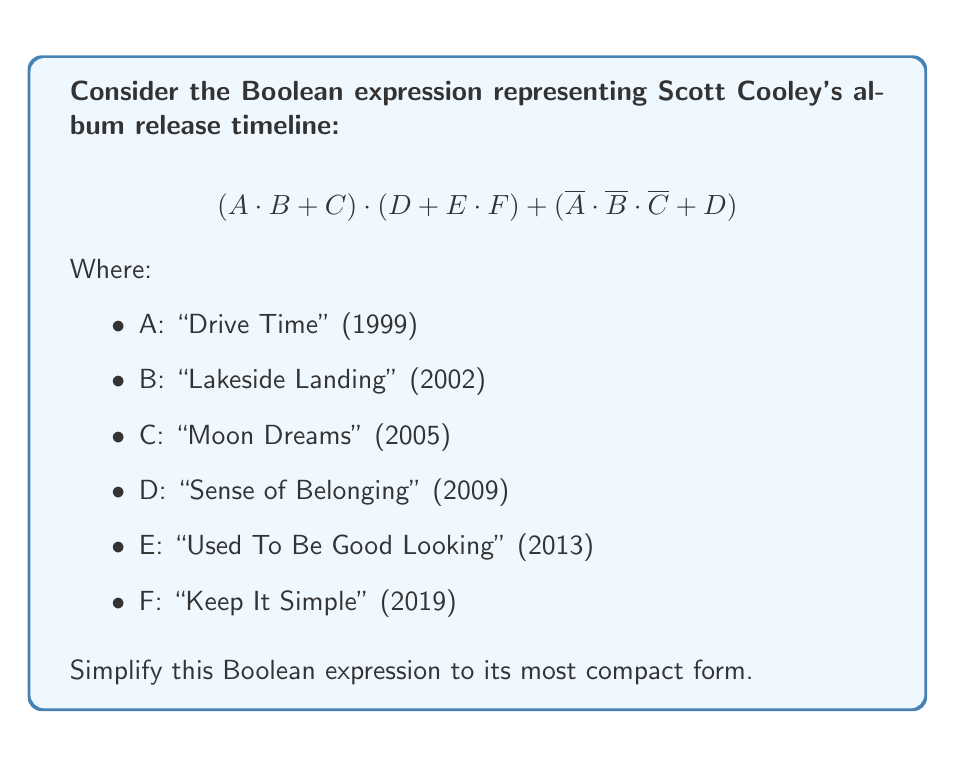Give your solution to this math problem. Let's simplify this expression step by step:

1) First, let's focus on the left part of the expression:
   $$(A \cdot B + C) \cdot (D + E \cdot F)$$
   
   Distribute $(A \cdot B + C)$ over $(D + E \cdot F)$:
   $$A \cdot B \cdot D + A \cdot B \cdot E \cdot F + C \cdot D + C \cdot E \cdot F$$

2) Now, let's look at the right part:
   $$\overline{A} \cdot \overline{B} \cdot \overline{C} + D$$

3) Combining the results from steps 1 and 2:
   $$A \cdot B \cdot D + A \cdot B \cdot E \cdot F + C \cdot D + C \cdot E \cdot F + \overline{A} \cdot \overline{B} \cdot \overline{C} + D$$

4) We can factor out D:
   $$D \cdot (A \cdot B + C + 1) + A \cdot B \cdot E \cdot F + C \cdot E \cdot F + \overline{A} \cdot \overline{B} \cdot \overline{C}$$

5) Note that $(A \cdot B + C + 1) = 1$ in Boolean algebra, so:
   $$D + A \cdot B \cdot E \cdot F + C \cdot E \cdot F + \overline{A} \cdot \overline{B} \cdot \overline{C}$$

6) This is the most simplified form we can achieve without losing information about specific album releases.
Answer: $$D + A \cdot B \cdot E \cdot F + C \cdot E \cdot F + \overline{A} \cdot \overline{B} \cdot \overline{C}$$ 